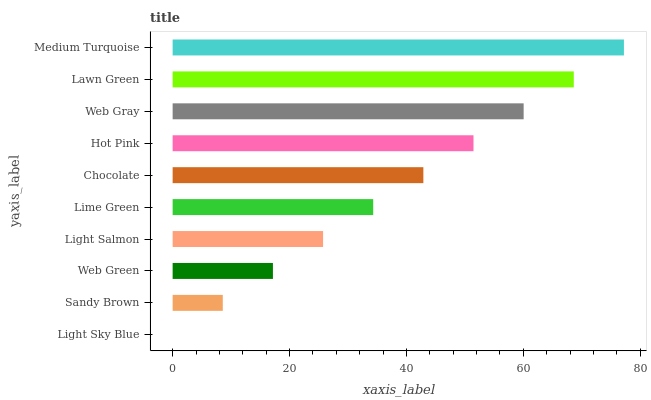Is Light Sky Blue the minimum?
Answer yes or no. Yes. Is Medium Turquoise the maximum?
Answer yes or no. Yes. Is Sandy Brown the minimum?
Answer yes or no. No. Is Sandy Brown the maximum?
Answer yes or no. No. Is Sandy Brown greater than Light Sky Blue?
Answer yes or no. Yes. Is Light Sky Blue less than Sandy Brown?
Answer yes or no. Yes. Is Light Sky Blue greater than Sandy Brown?
Answer yes or no. No. Is Sandy Brown less than Light Sky Blue?
Answer yes or no. No. Is Chocolate the high median?
Answer yes or no. Yes. Is Lime Green the low median?
Answer yes or no. Yes. Is Sandy Brown the high median?
Answer yes or no. No. Is Hot Pink the low median?
Answer yes or no. No. 